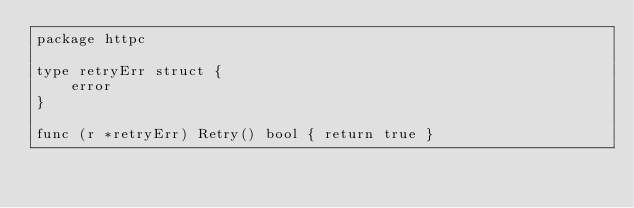Convert code to text. <code><loc_0><loc_0><loc_500><loc_500><_Go_>package httpc

type retryErr struct {
	error
}

func (r *retryErr) Retry() bool { return true }
</code> 